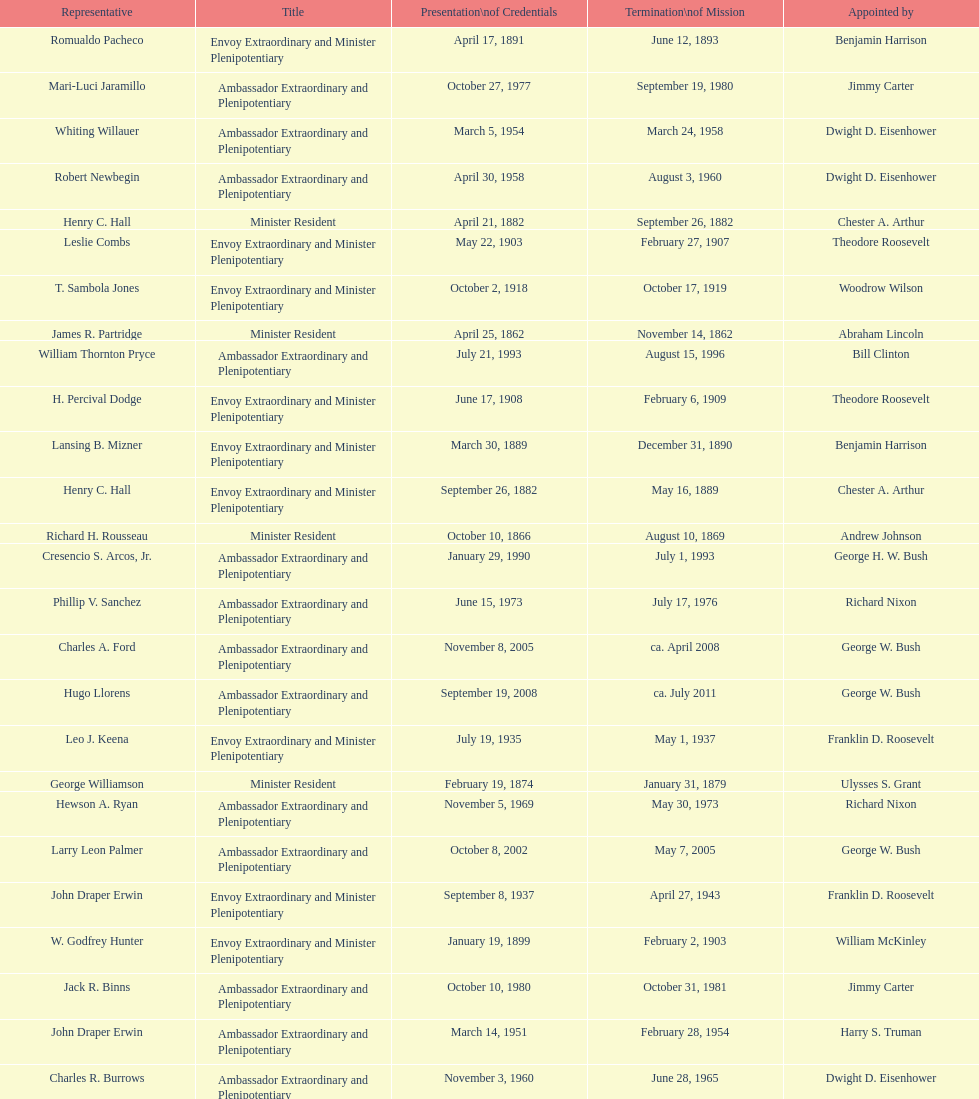Write the full table. {'header': ['Representative', 'Title', 'Presentation\\nof Credentials', 'Termination\\nof Mission', 'Appointed by'], 'rows': [['Romualdo Pacheco', 'Envoy Extraordinary and Minister Plenipotentiary', 'April 17, 1891', 'June 12, 1893', 'Benjamin Harrison'], ['Mari-Luci Jaramillo', 'Ambassador Extraordinary and Plenipotentiary', 'October 27, 1977', 'September 19, 1980', 'Jimmy Carter'], ['Whiting Willauer', 'Ambassador Extraordinary and Plenipotentiary', 'March 5, 1954', 'March 24, 1958', 'Dwight D. Eisenhower'], ['Robert Newbegin', 'Ambassador Extraordinary and Plenipotentiary', 'April 30, 1958', 'August 3, 1960', 'Dwight D. Eisenhower'], ['Henry C. Hall', 'Minister Resident', 'April 21, 1882', 'September 26, 1882', 'Chester A. Arthur'], ['Leslie Combs', 'Envoy Extraordinary and Minister Plenipotentiary', 'May 22, 1903', 'February 27, 1907', 'Theodore Roosevelt'], ['T. Sambola Jones', 'Envoy Extraordinary and Minister Plenipotentiary', 'October 2, 1918', 'October 17, 1919', 'Woodrow Wilson'], ['James R. Partridge', 'Minister Resident', 'April 25, 1862', 'November 14, 1862', 'Abraham Lincoln'], ['William Thornton Pryce', 'Ambassador Extraordinary and Plenipotentiary', 'July 21, 1993', 'August 15, 1996', 'Bill Clinton'], ['H. Percival Dodge', 'Envoy Extraordinary and Minister Plenipotentiary', 'June 17, 1908', 'February 6, 1909', 'Theodore Roosevelt'], ['Lansing B. Mizner', 'Envoy Extraordinary and Minister Plenipotentiary', 'March 30, 1889', 'December 31, 1890', 'Benjamin Harrison'], ['Henry C. Hall', 'Envoy Extraordinary and Minister Plenipotentiary', 'September 26, 1882', 'May 16, 1889', 'Chester A. Arthur'], ['Richard H. Rousseau', 'Minister Resident', 'October 10, 1866', 'August 10, 1869', 'Andrew Johnson'], ['Cresencio S. Arcos, Jr.', 'Ambassador Extraordinary and Plenipotentiary', 'January 29, 1990', 'July 1, 1993', 'George H. W. Bush'], ['Phillip V. Sanchez', 'Ambassador Extraordinary and Plenipotentiary', 'June 15, 1973', 'July 17, 1976', 'Richard Nixon'], ['Charles A. Ford', 'Ambassador Extraordinary and Plenipotentiary', 'November 8, 2005', 'ca. April 2008', 'George W. Bush'], ['Hugo Llorens', 'Ambassador Extraordinary and Plenipotentiary', 'September 19, 2008', 'ca. July 2011', 'George W. Bush'], ['Leo J. Keena', 'Envoy Extraordinary and Minister Plenipotentiary', 'July 19, 1935', 'May 1, 1937', 'Franklin D. Roosevelt'], ['George Williamson', 'Minister Resident', 'February 19, 1874', 'January 31, 1879', 'Ulysses S. Grant'], ['Hewson A. Ryan', 'Ambassador Extraordinary and Plenipotentiary', 'November 5, 1969', 'May 30, 1973', 'Richard Nixon'], ['Larry Leon Palmer', 'Ambassador Extraordinary and Plenipotentiary', 'October 8, 2002', 'May 7, 2005', 'George W. Bush'], ['John Draper Erwin', 'Envoy Extraordinary and Minister Plenipotentiary', 'September 8, 1937', 'April 27, 1943', 'Franklin D. Roosevelt'], ['W. Godfrey Hunter', 'Envoy Extraordinary and Minister Plenipotentiary', 'January 19, 1899', 'February 2, 1903', 'William McKinley'], ['Jack R. Binns', 'Ambassador Extraordinary and Plenipotentiary', 'October 10, 1980', 'October 31, 1981', 'Jimmy Carter'], ['John Draper Erwin', 'Ambassador Extraordinary and Plenipotentiary', 'March 14, 1951', 'February 28, 1954', 'Harry S. Truman'], ['Charles R. Burrows', 'Ambassador Extraordinary and Plenipotentiary', 'November 3, 1960', 'June 28, 1965', 'Dwight D. Eisenhower'], ['Frank Almaguer', 'Ambassador Extraordinary and Plenipotentiary', 'August 25, 1999', 'September 5, 2002', 'Bill Clinton'], ['Lisa Kubiske', 'Ambassador Extraordinary and Plenipotentiary', 'July 26, 2011', 'Incumbent', 'Barack Obama'], ['Thomas H. Clay', 'Minister Resident', 'April 5, 1864', 'August 10, 1866', 'Abraham Lincoln'], ['Fenton R. McCreery', 'Envoy Extraordinary and Minister Plenipotentiary', 'March 10, 1910', 'July 2, 1911', 'William H. Taft'], ['James F. Creagan', 'Ambassador Extraordinary and Plenipotentiary', 'August 29, 1996', 'July 20, 1999', 'Bill Clinton'], ['George T. Summerlin', 'Envoy Extraordinary and Minister Plenipotentiary', 'November 21, 1925', 'December 17, 1929', 'Calvin Coolidge'], ['John D. Negroponte', 'Ambassador Extraordinary and Plenipotentiary', 'November 11, 1981', 'May 30, 1985', 'Ronald Reagan'], ['Franklin E. Morales', 'Envoy Extraordinary and Minister Plenipotentiary', 'January 18, 1922', 'March 2, 1925', 'Warren G. Harding'], ['Paul C. Daniels', 'Ambassador Extraordinary and Plenipotentiary', 'June 23, 1947', 'October 30, 1947', 'Harry S. Truman'], ['Herbert S. Bursley', 'Ambassador Extraordinary and Plenipotentiary', 'May 15, 1948', 'December 12, 1950', 'Harry S. Truman'], ['John Ewing', 'Envoy Extraordinary and Minister Plenipotentiary', 'December 26, 1913', 'January 18, 1918', 'Woodrow Wilson'], ['Ralph E. Becker', 'Ambassador Extraordinary and Plenipotentiary', 'October 27, 1976', 'August 1, 1977', 'Gerald Ford'], ['Philip Marshall Brown', 'Envoy Extraordinary and Minister Plenipotentiary', 'February 21, 1909', 'February 26, 1910', 'Theodore Roosevelt'], ['Henry Baxter', 'Minister Resident', 'August 10, 1869', 'June 30, 1873', 'Ulysses S. Grant'], ['Charles Dunning White', 'Envoy Extraordinary and Minister Plenipotentiary', 'September 9, 1911', 'November 4, 1913', 'William H. Taft'], ['Macgrane Coxe', 'Envoy Extraordinary and Minister Plenipotentiary', '', 'June 30, 1897', 'Grover Cleveland'], ['John Arthur Ferch', 'Ambassador Extraordinary and Plenipotentiary', 'August 22, 1985', 'July 9, 1986', 'Ronald Reagan'], ['Pierce M. B. Young', 'Envoy Extraordinary and Minister Plenipotentiary', 'November 12, 1893', 'May 23, 1896', 'Grover Cleveland'], ['Beverly L. Clarke', 'Minister Resident', 'August 10, 1858', 'March 17, 1860', 'James Buchanan'], ['Solon Borland', 'Envoy Extraordinary and Minister Plenipotentiary', '', 'April 17, 1854', 'Franklin Pierce'], ['John Draper Erwin', 'Ambassador Extraordinary and Plenipotentiary', 'April 27, 1943', 'April 16, 1947', 'Franklin D. Roosevelt'], ['Joseph J. Jova', 'Ambassador Extraordinary and Plenipotentiary', 'July 12, 1965', 'June 21, 1969', 'Lyndon B. Johnson'], ['Joseph W. J. Lee', 'Envoy Extraordinary and Minister Plenipotentiary', '', 'July 1, 1907', 'Theodore Roosevelt'], ['Julius G. Lay', 'Envoy Extraordinary and Minister Plenipotentiary', 'May 31, 1930', 'March 17, 1935', 'Herbert Hoover'], ['Everett Ellis Briggs', 'Ambassador Extraordinary and Plenipotentiary', 'November 4, 1986', 'June 15, 1989', 'Ronald Reagan'], ['Cornelius A. Logan', 'Minister Resident', 'October 10, 1879', 'April 15, 1882', 'Rutherford B. Hayes']]} Which ambassador to honduras served the longest term? Henry C. Hall. 